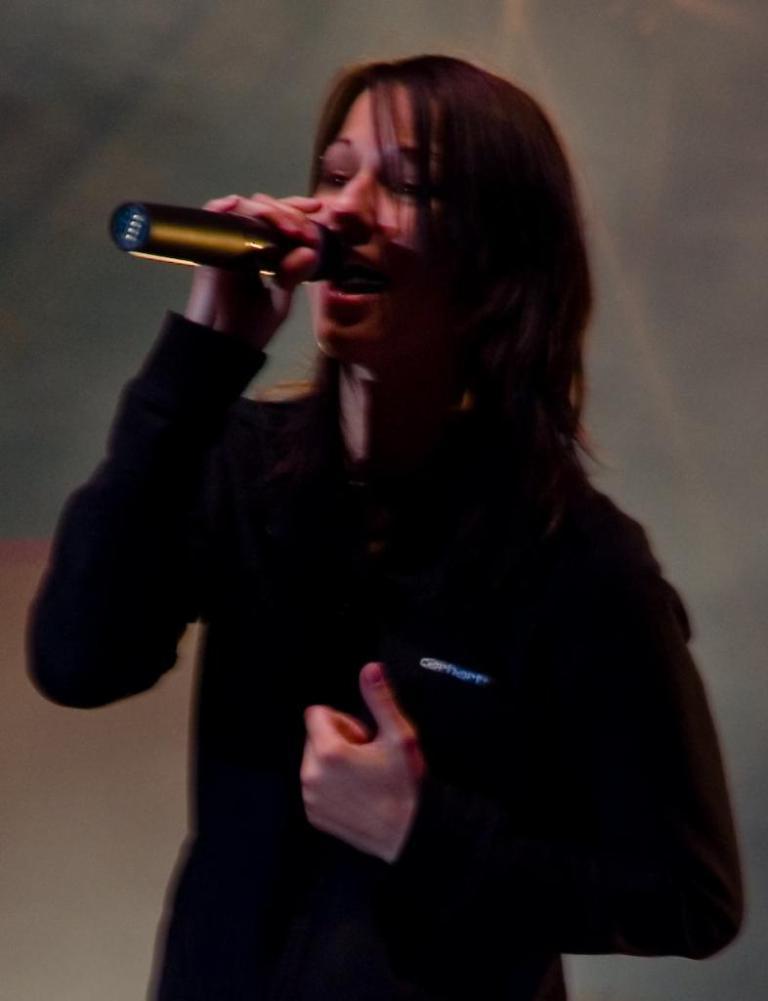Please provide a concise description of this image. In this image I can see a woman wearing black color dress is standing and holding a black colored microphone. I can see the blurry background. 